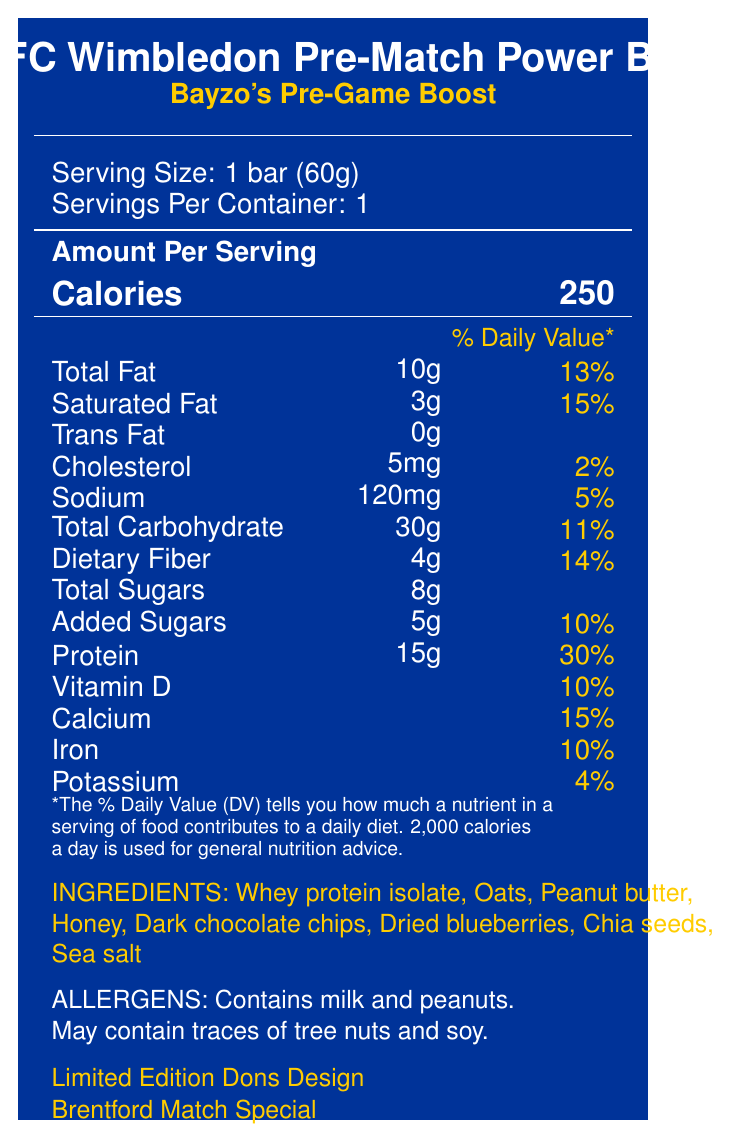what is the serving size? The serving size is clearly listed under "Serving Size" and specifies "1 bar (60g)".
Answer: 1 bar (60g) how many grams of protein are in one serving? Under "Amount Per Serving," it lists "Protein: 15g."
Answer: 15g what is the percentage of daily value for dietary fiber? The nutritional information shows that Dietary Fiber contributes 14% to the daily value.
Answer: 14% how many total sugars are in the protein bar? The label states "Total Sugars" at 8g.
Answer: 8g does the product contain tree nuts? Under the "ALLERGENS" section, it mentions "May contain traces of tree nuts and soy."
Answer: May contain traces of tree nuts what is the main protein source listed in the ingredients? The first ingredient listed is "Whey protein isolate," indicating it is the primary protein source.
Answer: Whey protein isolate what special features does this protein bar offer? The "specialFeatures" section highlights three special features.
Answer: Bayzo's Pre-Game Boost, Limited Edition Dons Design, Brentford Match Special how much calcium does one bar provide? A. 50mg B. 150mg C. 200mg D. 250mg According to the nutritional facts, each bar contains 200mg of calcium.
Answer: C. 200mg what is the brand information labeled on the protein bar? A. AFC Wimbledon Merchandise B. Brentford FC Edition C. EPL Official Product The label mentions "Official AFC Wimbledon Merchandise."
Answer: A. AFC Wimbledon Merchandise which allergen is definitely present in the bar? A. Tree nuts B. Soy C. Milk D. Shellfish The allergens section lists "Contains milk and peanuts."
Answer: C. Milk is this product intended to be consumed before or after the game? The storage and consumption instructions recommend consuming the bar before kick-off.
Answer: Before does this bar contain any trans fat? The nutritional facts list "Trans Fat: 0g."
Answer: No summarize the information provided in the document The document provides comprehensive details about the nutritional content, ingredients, and special features of a limited-edition protein bar designed for AFC Wimbledon fans, emphasizing its pre-game energy boost.
Answer: The document describes the nutrition facts for an AFC Wimbledon Pre-Match Power Bar. It includes detailed nutritional information per serving (1 bar, 60g), ingredients, allergens, special features, and brand information. The bar offers significant protein, dietary fiber, and essential vitamins and minerals, making it a suitable pre-game snack. Special features include Bayzo's Pre-Game Boost and a Limited Edition Dons Design for the Brentford match. what is the total caloric contribution from fat in one bar? The document does not provide enough information to calculate the exact caloric contribution from fat directly.
Answer: Cannot be determined 